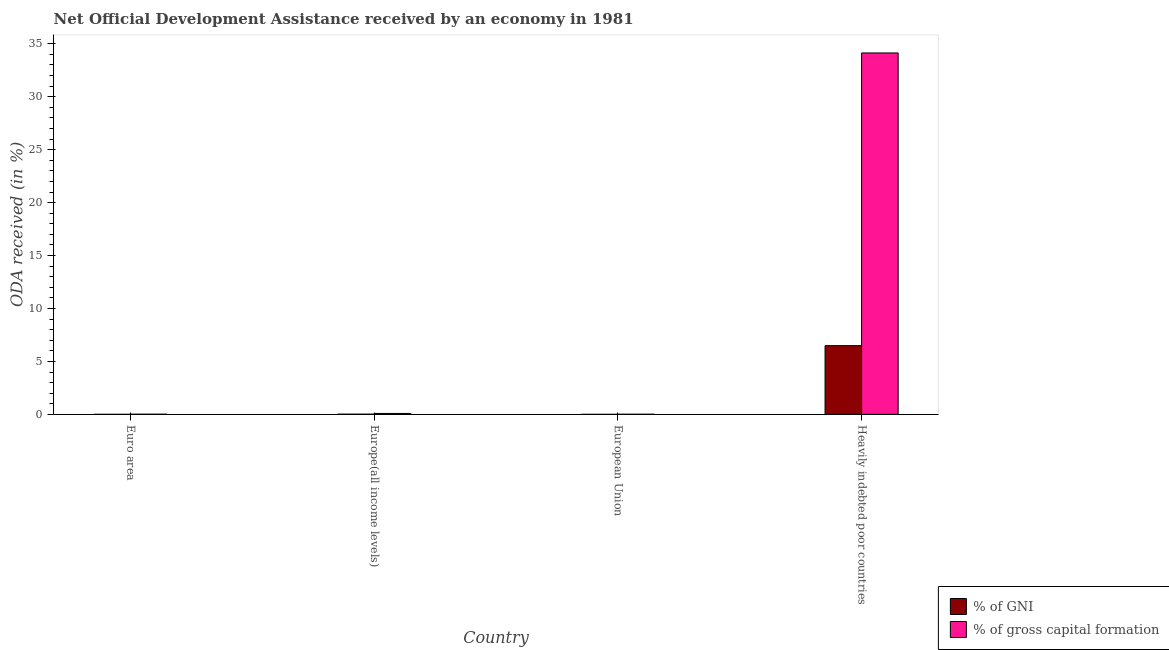Are the number of bars per tick equal to the number of legend labels?
Your answer should be very brief. Yes. How many bars are there on the 2nd tick from the left?
Offer a terse response. 2. How many bars are there on the 3rd tick from the right?
Offer a very short reply. 2. What is the label of the 1st group of bars from the left?
Offer a very short reply. Euro area. In how many cases, is the number of bars for a given country not equal to the number of legend labels?
Ensure brevity in your answer.  0. What is the oda received as percentage of gni in Heavily indebted poor countries?
Your answer should be compact. 6.49. Across all countries, what is the maximum oda received as percentage of gross capital formation?
Your answer should be very brief. 34.13. Across all countries, what is the minimum oda received as percentage of gross capital formation?
Your response must be concise. 0.01. In which country was the oda received as percentage of gni maximum?
Give a very brief answer. Heavily indebted poor countries. In which country was the oda received as percentage of gross capital formation minimum?
Offer a very short reply. European Union. What is the total oda received as percentage of gni in the graph?
Ensure brevity in your answer.  6.52. What is the difference between the oda received as percentage of gni in Euro area and that in European Union?
Offer a terse response. 0. What is the difference between the oda received as percentage of gni in Euro area and the oda received as percentage of gross capital formation in European Union?
Give a very brief answer. -0.01. What is the average oda received as percentage of gross capital formation per country?
Give a very brief answer. 8.56. What is the difference between the oda received as percentage of gni and oda received as percentage of gross capital formation in Euro area?
Provide a short and direct response. -0.01. What is the ratio of the oda received as percentage of gni in European Union to that in Heavily indebted poor countries?
Keep it short and to the point. 0. What is the difference between the highest and the second highest oda received as percentage of gni?
Make the answer very short. 6.47. What is the difference between the highest and the lowest oda received as percentage of gross capital formation?
Provide a short and direct response. 34.12. Is the sum of the oda received as percentage of gni in Euro area and European Union greater than the maximum oda received as percentage of gross capital formation across all countries?
Offer a very short reply. No. What does the 1st bar from the left in Europe(all income levels) represents?
Make the answer very short. % of GNI. What does the 2nd bar from the right in Heavily indebted poor countries represents?
Your answer should be very brief. % of GNI. What is the difference between two consecutive major ticks on the Y-axis?
Your answer should be very brief. 5. Are the values on the major ticks of Y-axis written in scientific E-notation?
Give a very brief answer. No. Does the graph contain grids?
Offer a terse response. No. Where does the legend appear in the graph?
Offer a very short reply. Bottom right. How many legend labels are there?
Give a very brief answer. 2. What is the title of the graph?
Make the answer very short. Net Official Development Assistance received by an economy in 1981. What is the label or title of the X-axis?
Provide a succinct answer. Country. What is the label or title of the Y-axis?
Make the answer very short. ODA received (in %). What is the ODA received (in %) in % of GNI in Euro area?
Your answer should be compact. 0. What is the ODA received (in %) of % of gross capital formation in Euro area?
Offer a terse response. 0.02. What is the ODA received (in %) of % of GNI in Europe(all income levels)?
Provide a succinct answer. 0.02. What is the ODA received (in %) of % of gross capital formation in Europe(all income levels)?
Keep it short and to the point. 0.09. What is the ODA received (in %) of % of GNI in European Union?
Your answer should be compact. 0. What is the ODA received (in %) in % of gross capital formation in European Union?
Your answer should be very brief. 0.01. What is the ODA received (in %) of % of GNI in Heavily indebted poor countries?
Give a very brief answer. 6.49. What is the ODA received (in %) of % of gross capital formation in Heavily indebted poor countries?
Make the answer very short. 34.13. Across all countries, what is the maximum ODA received (in %) of % of GNI?
Your answer should be compact. 6.49. Across all countries, what is the maximum ODA received (in %) in % of gross capital formation?
Provide a short and direct response. 34.13. Across all countries, what is the minimum ODA received (in %) of % of GNI?
Your answer should be compact. 0. Across all countries, what is the minimum ODA received (in %) of % of gross capital formation?
Ensure brevity in your answer.  0.01. What is the total ODA received (in %) in % of GNI in the graph?
Your response must be concise. 6.52. What is the total ODA received (in %) in % of gross capital formation in the graph?
Your answer should be compact. 34.25. What is the difference between the ODA received (in %) of % of GNI in Euro area and that in Europe(all income levels)?
Your response must be concise. -0.02. What is the difference between the ODA received (in %) in % of gross capital formation in Euro area and that in Europe(all income levels)?
Offer a terse response. -0.07. What is the difference between the ODA received (in %) in % of GNI in Euro area and that in European Union?
Your answer should be compact. 0. What is the difference between the ODA received (in %) of % of gross capital formation in Euro area and that in European Union?
Give a very brief answer. 0. What is the difference between the ODA received (in %) in % of GNI in Euro area and that in Heavily indebted poor countries?
Ensure brevity in your answer.  -6.49. What is the difference between the ODA received (in %) of % of gross capital formation in Euro area and that in Heavily indebted poor countries?
Keep it short and to the point. -34.12. What is the difference between the ODA received (in %) of % of GNI in Europe(all income levels) and that in European Union?
Offer a very short reply. 0.02. What is the difference between the ODA received (in %) of % of gross capital formation in Europe(all income levels) and that in European Union?
Your answer should be compact. 0.07. What is the difference between the ODA received (in %) of % of GNI in Europe(all income levels) and that in Heavily indebted poor countries?
Your answer should be very brief. -6.47. What is the difference between the ODA received (in %) of % of gross capital formation in Europe(all income levels) and that in Heavily indebted poor countries?
Provide a succinct answer. -34.05. What is the difference between the ODA received (in %) in % of GNI in European Union and that in Heavily indebted poor countries?
Provide a succinct answer. -6.49. What is the difference between the ODA received (in %) of % of gross capital formation in European Union and that in Heavily indebted poor countries?
Offer a very short reply. -34.12. What is the difference between the ODA received (in %) in % of GNI in Euro area and the ODA received (in %) in % of gross capital formation in Europe(all income levels)?
Keep it short and to the point. -0.08. What is the difference between the ODA received (in %) of % of GNI in Euro area and the ODA received (in %) of % of gross capital formation in European Union?
Your answer should be very brief. -0.01. What is the difference between the ODA received (in %) of % of GNI in Euro area and the ODA received (in %) of % of gross capital formation in Heavily indebted poor countries?
Your answer should be very brief. -34.13. What is the difference between the ODA received (in %) of % of GNI in Europe(all income levels) and the ODA received (in %) of % of gross capital formation in European Union?
Your response must be concise. 0.01. What is the difference between the ODA received (in %) in % of GNI in Europe(all income levels) and the ODA received (in %) in % of gross capital formation in Heavily indebted poor countries?
Your response must be concise. -34.11. What is the difference between the ODA received (in %) in % of GNI in European Union and the ODA received (in %) in % of gross capital formation in Heavily indebted poor countries?
Your response must be concise. -34.13. What is the average ODA received (in %) in % of GNI per country?
Your answer should be compact. 1.63. What is the average ODA received (in %) in % of gross capital formation per country?
Provide a succinct answer. 8.56. What is the difference between the ODA received (in %) of % of GNI and ODA received (in %) of % of gross capital formation in Euro area?
Give a very brief answer. -0.01. What is the difference between the ODA received (in %) in % of GNI and ODA received (in %) in % of gross capital formation in Europe(all income levels)?
Offer a very short reply. -0.07. What is the difference between the ODA received (in %) in % of GNI and ODA received (in %) in % of gross capital formation in European Union?
Your answer should be compact. -0.01. What is the difference between the ODA received (in %) of % of GNI and ODA received (in %) of % of gross capital formation in Heavily indebted poor countries?
Give a very brief answer. -27.64. What is the ratio of the ODA received (in %) in % of GNI in Euro area to that in Europe(all income levels)?
Provide a succinct answer. 0.18. What is the ratio of the ODA received (in %) of % of gross capital formation in Euro area to that in Europe(all income levels)?
Keep it short and to the point. 0.17. What is the ratio of the ODA received (in %) of % of GNI in Euro area to that in European Union?
Your response must be concise. 1.32. What is the ratio of the ODA received (in %) of % of gross capital formation in Euro area to that in European Union?
Offer a very short reply. 1.27. What is the ratio of the ODA received (in %) of % of GNI in Euro area to that in Heavily indebted poor countries?
Your answer should be compact. 0. What is the ratio of the ODA received (in %) of % of GNI in Europe(all income levels) to that in European Union?
Give a very brief answer. 7.48. What is the ratio of the ODA received (in %) of % of gross capital formation in Europe(all income levels) to that in European Union?
Keep it short and to the point. 7.31. What is the ratio of the ODA received (in %) in % of GNI in Europe(all income levels) to that in Heavily indebted poor countries?
Make the answer very short. 0. What is the ratio of the ODA received (in %) of % of gross capital formation in Europe(all income levels) to that in Heavily indebted poor countries?
Give a very brief answer. 0. What is the ratio of the ODA received (in %) in % of GNI in European Union to that in Heavily indebted poor countries?
Your answer should be very brief. 0. What is the ratio of the ODA received (in %) in % of gross capital formation in European Union to that in Heavily indebted poor countries?
Provide a short and direct response. 0. What is the difference between the highest and the second highest ODA received (in %) of % of GNI?
Ensure brevity in your answer.  6.47. What is the difference between the highest and the second highest ODA received (in %) in % of gross capital formation?
Provide a succinct answer. 34.05. What is the difference between the highest and the lowest ODA received (in %) in % of GNI?
Provide a short and direct response. 6.49. What is the difference between the highest and the lowest ODA received (in %) in % of gross capital formation?
Offer a very short reply. 34.12. 